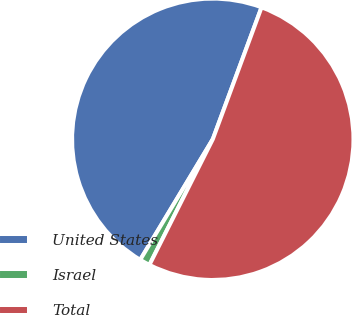<chart> <loc_0><loc_0><loc_500><loc_500><pie_chart><fcel>United States<fcel>Israel<fcel>Total<nl><fcel>47.01%<fcel>1.19%<fcel>51.8%<nl></chart> 